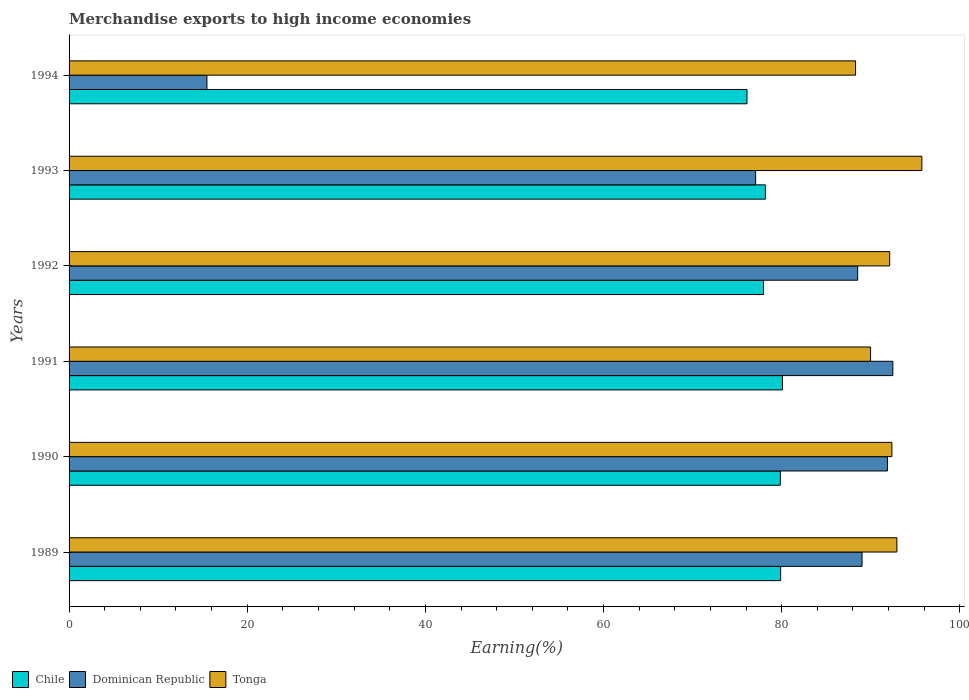How many groups of bars are there?
Give a very brief answer. 6. Are the number of bars on each tick of the Y-axis equal?
Ensure brevity in your answer.  Yes. How many bars are there on the 4th tick from the top?
Ensure brevity in your answer.  3. How many bars are there on the 2nd tick from the bottom?
Offer a very short reply. 3. What is the percentage of amount earned from merchandise exports in Tonga in 1991?
Your answer should be very brief. 89.98. Across all years, what is the maximum percentage of amount earned from merchandise exports in Tonga?
Ensure brevity in your answer.  95.74. Across all years, what is the minimum percentage of amount earned from merchandise exports in Dominican Republic?
Ensure brevity in your answer.  15.48. In which year was the percentage of amount earned from merchandise exports in Dominican Republic maximum?
Offer a terse response. 1991. In which year was the percentage of amount earned from merchandise exports in Chile minimum?
Make the answer very short. 1994. What is the total percentage of amount earned from merchandise exports in Chile in the graph?
Offer a terse response. 472.06. What is the difference between the percentage of amount earned from merchandise exports in Tonga in 1992 and that in 1994?
Offer a terse response. 3.83. What is the difference between the percentage of amount earned from merchandise exports in Chile in 1990 and the percentage of amount earned from merchandise exports in Tonga in 1991?
Your answer should be very brief. -10.13. What is the average percentage of amount earned from merchandise exports in Tonga per year?
Provide a succinct answer. 91.91. In the year 1993, what is the difference between the percentage of amount earned from merchandise exports in Chile and percentage of amount earned from merchandise exports in Dominican Republic?
Your response must be concise. 1.1. In how many years, is the percentage of amount earned from merchandise exports in Dominican Republic greater than 84 %?
Provide a succinct answer. 4. What is the ratio of the percentage of amount earned from merchandise exports in Chile in 1989 to that in 1992?
Your response must be concise. 1.02. Is the percentage of amount earned from merchandise exports in Chile in 1989 less than that in 1992?
Your answer should be compact. No. What is the difference between the highest and the second highest percentage of amount earned from merchandise exports in Tonga?
Provide a succinct answer. 2.8. What is the difference between the highest and the lowest percentage of amount earned from merchandise exports in Dominican Republic?
Offer a terse response. 77. What does the 1st bar from the top in 1991 represents?
Your answer should be compact. Tonga. What does the 2nd bar from the bottom in 1994 represents?
Ensure brevity in your answer.  Dominican Republic. Are all the bars in the graph horizontal?
Make the answer very short. Yes. How many years are there in the graph?
Your answer should be very brief. 6. Are the values on the major ticks of X-axis written in scientific E-notation?
Give a very brief answer. No. Does the graph contain any zero values?
Your answer should be compact. No. Does the graph contain grids?
Offer a terse response. No. How are the legend labels stacked?
Offer a terse response. Horizontal. What is the title of the graph?
Provide a succinct answer. Merchandise exports to high income economies. Does "Kyrgyz Republic" appear as one of the legend labels in the graph?
Keep it short and to the point. No. What is the label or title of the X-axis?
Provide a short and direct response. Earning(%). What is the Earning(%) of Chile in 1989?
Offer a very short reply. 79.88. What is the Earning(%) of Dominican Republic in 1989?
Your answer should be compact. 89.02. What is the Earning(%) in Tonga in 1989?
Offer a very short reply. 92.94. What is the Earning(%) of Chile in 1990?
Keep it short and to the point. 79.85. What is the Earning(%) of Dominican Republic in 1990?
Your answer should be compact. 91.88. What is the Earning(%) of Tonga in 1990?
Provide a succinct answer. 92.37. What is the Earning(%) in Chile in 1991?
Your response must be concise. 80.09. What is the Earning(%) of Dominican Republic in 1991?
Provide a succinct answer. 92.48. What is the Earning(%) of Tonga in 1991?
Keep it short and to the point. 89.98. What is the Earning(%) of Chile in 1992?
Offer a very short reply. 77.96. What is the Earning(%) of Dominican Republic in 1992?
Give a very brief answer. 88.53. What is the Earning(%) of Tonga in 1992?
Offer a terse response. 92.13. What is the Earning(%) in Chile in 1993?
Your answer should be compact. 78.17. What is the Earning(%) of Dominican Republic in 1993?
Ensure brevity in your answer.  77.08. What is the Earning(%) in Tonga in 1993?
Make the answer very short. 95.74. What is the Earning(%) in Chile in 1994?
Ensure brevity in your answer.  76.11. What is the Earning(%) in Dominican Republic in 1994?
Your answer should be compact. 15.48. What is the Earning(%) in Tonga in 1994?
Your answer should be very brief. 88.29. Across all years, what is the maximum Earning(%) of Chile?
Provide a short and direct response. 80.09. Across all years, what is the maximum Earning(%) in Dominican Republic?
Keep it short and to the point. 92.48. Across all years, what is the maximum Earning(%) in Tonga?
Ensure brevity in your answer.  95.74. Across all years, what is the minimum Earning(%) in Chile?
Your answer should be compact. 76.11. Across all years, what is the minimum Earning(%) of Dominican Republic?
Your answer should be compact. 15.48. Across all years, what is the minimum Earning(%) of Tonga?
Keep it short and to the point. 88.29. What is the total Earning(%) of Chile in the graph?
Give a very brief answer. 472.06. What is the total Earning(%) in Dominican Republic in the graph?
Offer a terse response. 454.46. What is the total Earning(%) in Tonga in the graph?
Your answer should be very brief. 551.45. What is the difference between the Earning(%) of Chile in 1989 and that in 1990?
Provide a short and direct response. 0.03. What is the difference between the Earning(%) in Dominican Republic in 1989 and that in 1990?
Make the answer very short. -2.85. What is the difference between the Earning(%) of Tonga in 1989 and that in 1990?
Your answer should be compact. 0.56. What is the difference between the Earning(%) of Chile in 1989 and that in 1991?
Ensure brevity in your answer.  -0.2. What is the difference between the Earning(%) of Dominican Republic in 1989 and that in 1991?
Ensure brevity in your answer.  -3.46. What is the difference between the Earning(%) in Tonga in 1989 and that in 1991?
Ensure brevity in your answer.  2.96. What is the difference between the Earning(%) of Chile in 1989 and that in 1992?
Ensure brevity in your answer.  1.92. What is the difference between the Earning(%) of Dominican Republic in 1989 and that in 1992?
Give a very brief answer. 0.49. What is the difference between the Earning(%) of Tonga in 1989 and that in 1992?
Keep it short and to the point. 0.81. What is the difference between the Earning(%) of Chile in 1989 and that in 1993?
Offer a very short reply. 1.71. What is the difference between the Earning(%) in Dominican Republic in 1989 and that in 1993?
Your answer should be compact. 11.95. What is the difference between the Earning(%) of Tonga in 1989 and that in 1993?
Give a very brief answer. -2.8. What is the difference between the Earning(%) of Chile in 1989 and that in 1994?
Your response must be concise. 3.78. What is the difference between the Earning(%) in Dominican Republic in 1989 and that in 1994?
Provide a short and direct response. 73.55. What is the difference between the Earning(%) of Tonga in 1989 and that in 1994?
Provide a short and direct response. 4.64. What is the difference between the Earning(%) of Chile in 1990 and that in 1991?
Offer a very short reply. -0.23. What is the difference between the Earning(%) of Dominican Republic in 1990 and that in 1991?
Provide a succinct answer. -0.6. What is the difference between the Earning(%) of Tonga in 1990 and that in 1991?
Offer a very short reply. 2.4. What is the difference between the Earning(%) of Chile in 1990 and that in 1992?
Keep it short and to the point. 1.89. What is the difference between the Earning(%) of Dominican Republic in 1990 and that in 1992?
Your answer should be compact. 3.34. What is the difference between the Earning(%) of Tonga in 1990 and that in 1992?
Your response must be concise. 0.25. What is the difference between the Earning(%) in Chile in 1990 and that in 1993?
Your response must be concise. 1.68. What is the difference between the Earning(%) of Dominican Republic in 1990 and that in 1993?
Make the answer very short. 14.8. What is the difference between the Earning(%) in Tonga in 1990 and that in 1993?
Keep it short and to the point. -3.36. What is the difference between the Earning(%) in Chile in 1990 and that in 1994?
Offer a very short reply. 3.75. What is the difference between the Earning(%) in Dominican Republic in 1990 and that in 1994?
Your response must be concise. 76.4. What is the difference between the Earning(%) in Tonga in 1990 and that in 1994?
Ensure brevity in your answer.  4.08. What is the difference between the Earning(%) in Chile in 1991 and that in 1992?
Your answer should be compact. 2.12. What is the difference between the Earning(%) of Dominican Republic in 1991 and that in 1992?
Provide a short and direct response. 3.95. What is the difference between the Earning(%) of Tonga in 1991 and that in 1992?
Provide a short and direct response. -2.15. What is the difference between the Earning(%) of Chile in 1991 and that in 1993?
Provide a succinct answer. 1.91. What is the difference between the Earning(%) of Dominican Republic in 1991 and that in 1993?
Your response must be concise. 15.4. What is the difference between the Earning(%) of Tonga in 1991 and that in 1993?
Your response must be concise. -5.76. What is the difference between the Earning(%) of Chile in 1991 and that in 1994?
Your answer should be very brief. 3.98. What is the difference between the Earning(%) in Dominican Republic in 1991 and that in 1994?
Your answer should be very brief. 77. What is the difference between the Earning(%) in Tonga in 1991 and that in 1994?
Provide a short and direct response. 1.68. What is the difference between the Earning(%) of Chile in 1992 and that in 1993?
Offer a very short reply. -0.21. What is the difference between the Earning(%) in Dominican Republic in 1992 and that in 1993?
Give a very brief answer. 11.46. What is the difference between the Earning(%) of Tonga in 1992 and that in 1993?
Your response must be concise. -3.61. What is the difference between the Earning(%) of Chile in 1992 and that in 1994?
Your answer should be very brief. 1.85. What is the difference between the Earning(%) in Dominican Republic in 1992 and that in 1994?
Your answer should be very brief. 73.06. What is the difference between the Earning(%) of Tonga in 1992 and that in 1994?
Your answer should be compact. 3.83. What is the difference between the Earning(%) of Chile in 1993 and that in 1994?
Provide a short and direct response. 2.06. What is the difference between the Earning(%) in Dominican Republic in 1993 and that in 1994?
Offer a very short reply. 61.6. What is the difference between the Earning(%) of Tonga in 1993 and that in 1994?
Offer a very short reply. 7.44. What is the difference between the Earning(%) of Chile in 1989 and the Earning(%) of Dominican Republic in 1990?
Make the answer very short. -11.99. What is the difference between the Earning(%) of Chile in 1989 and the Earning(%) of Tonga in 1990?
Offer a terse response. -12.49. What is the difference between the Earning(%) of Dominican Republic in 1989 and the Earning(%) of Tonga in 1990?
Make the answer very short. -3.35. What is the difference between the Earning(%) in Chile in 1989 and the Earning(%) in Dominican Republic in 1991?
Ensure brevity in your answer.  -12.59. What is the difference between the Earning(%) in Chile in 1989 and the Earning(%) in Tonga in 1991?
Your response must be concise. -10.09. What is the difference between the Earning(%) in Dominican Republic in 1989 and the Earning(%) in Tonga in 1991?
Your response must be concise. -0.96. What is the difference between the Earning(%) of Chile in 1989 and the Earning(%) of Dominican Republic in 1992?
Your answer should be compact. -8.65. What is the difference between the Earning(%) in Chile in 1989 and the Earning(%) in Tonga in 1992?
Provide a short and direct response. -12.24. What is the difference between the Earning(%) of Dominican Republic in 1989 and the Earning(%) of Tonga in 1992?
Your answer should be very brief. -3.1. What is the difference between the Earning(%) of Chile in 1989 and the Earning(%) of Dominican Republic in 1993?
Keep it short and to the point. 2.81. What is the difference between the Earning(%) in Chile in 1989 and the Earning(%) in Tonga in 1993?
Make the answer very short. -15.85. What is the difference between the Earning(%) in Dominican Republic in 1989 and the Earning(%) in Tonga in 1993?
Give a very brief answer. -6.71. What is the difference between the Earning(%) in Chile in 1989 and the Earning(%) in Dominican Republic in 1994?
Your answer should be compact. 64.41. What is the difference between the Earning(%) of Chile in 1989 and the Earning(%) of Tonga in 1994?
Provide a succinct answer. -8.41. What is the difference between the Earning(%) of Dominican Republic in 1989 and the Earning(%) of Tonga in 1994?
Give a very brief answer. 0.73. What is the difference between the Earning(%) in Chile in 1990 and the Earning(%) in Dominican Republic in 1991?
Keep it short and to the point. -12.63. What is the difference between the Earning(%) in Chile in 1990 and the Earning(%) in Tonga in 1991?
Make the answer very short. -10.13. What is the difference between the Earning(%) in Dominican Republic in 1990 and the Earning(%) in Tonga in 1991?
Offer a terse response. 1.9. What is the difference between the Earning(%) of Chile in 1990 and the Earning(%) of Dominican Republic in 1992?
Your answer should be compact. -8.68. What is the difference between the Earning(%) of Chile in 1990 and the Earning(%) of Tonga in 1992?
Ensure brevity in your answer.  -12.27. What is the difference between the Earning(%) in Dominican Republic in 1990 and the Earning(%) in Tonga in 1992?
Your answer should be very brief. -0.25. What is the difference between the Earning(%) of Chile in 1990 and the Earning(%) of Dominican Republic in 1993?
Make the answer very short. 2.78. What is the difference between the Earning(%) in Chile in 1990 and the Earning(%) in Tonga in 1993?
Your answer should be very brief. -15.88. What is the difference between the Earning(%) in Dominican Republic in 1990 and the Earning(%) in Tonga in 1993?
Provide a succinct answer. -3.86. What is the difference between the Earning(%) of Chile in 1990 and the Earning(%) of Dominican Republic in 1994?
Provide a succinct answer. 64.38. What is the difference between the Earning(%) in Chile in 1990 and the Earning(%) in Tonga in 1994?
Your response must be concise. -8.44. What is the difference between the Earning(%) of Dominican Republic in 1990 and the Earning(%) of Tonga in 1994?
Offer a terse response. 3.58. What is the difference between the Earning(%) of Chile in 1991 and the Earning(%) of Dominican Republic in 1992?
Provide a short and direct response. -8.45. What is the difference between the Earning(%) in Chile in 1991 and the Earning(%) in Tonga in 1992?
Your answer should be compact. -12.04. What is the difference between the Earning(%) of Dominican Republic in 1991 and the Earning(%) of Tonga in 1992?
Ensure brevity in your answer.  0.35. What is the difference between the Earning(%) in Chile in 1991 and the Earning(%) in Dominican Republic in 1993?
Offer a very short reply. 3.01. What is the difference between the Earning(%) in Chile in 1991 and the Earning(%) in Tonga in 1993?
Offer a very short reply. -15.65. What is the difference between the Earning(%) in Dominican Republic in 1991 and the Earning(%) in Tonga in 1993?
Your answer should be compact. -3.26. What is the difference between the Earning(%) in Chile in 1991 and the Earning(%) in Dominican Republic in 1994?
Your response must be concise. 64.61. What is the difference between the Earning(%) of Chile in 1991 and the Earning(%) of Tonga in 1994?
Your response must be concise. -8.21. What is the difference between the Earning(%) in Dominican Republic in 1991 and the Earning(%) in Tonga in 1994?
Make the answer very short. 4.18. What is the difference between the Earning(%) of Chile in 1992 and the Earning(%) of Dominican Republic in 1993?
Your answer should be compact. 0.89. What is the difference between the Earning(%) of Chile in 1992 and the Earning(%) of Tonga in 1993?
Offer a terse response. -17.77. What is the difference between the Earning(%) of Dominican Republic in 1992 and the Earning(%) of Tonga in 1993?
Your response must be concise. -7.21. What is the difference between the Earning(%) in Chile in 1992 and the Earning(%) in Dominican Republic in 1994?
Your answer should be compact. 62.49. What is the difference between the Earning(%) in Chile in 1992 and the Earning(%) in Tonga in 1994?
Offer a very short reply. -10.33. What is the difference between the Earning(%) in Dominican Republic in 1992 and the Earning(%) in Tonga in 1994?
Keep it short and to the point. 0.24. What is the difference between the Earning(%) of Chile in 1993 and the Earning(%) of Dominican Republic in 1994?
Your response must be concise. 62.7. What is the difference between the Earning(%) in Chile in 1993 and the Earning(%) in Tonga in 1994?
Give a very brief answer. -10.12. What is the difference between the Earning(%) of Dominican Republic in 1993 and the Earning(%) of Tonga in 1994?
Your answer should be very brief. -11.22. What is the average Earning(%) in Chile per year?
Keep it short and to the point. 78.68. What is the average Earning(%) in Dominican Republic per year?
Offer a very short reply. 75.74. What is the average Earning(%) of Tonga per year?
Your answer should be compact. 91.91. In the year 1989, what is the difference between the Earning(%) of Chile and Earning(%) of Dominican Republic?
Provide a succinct answer. -9.14. In the year 1989, what is the difference between the Earning(%) in Chile and Earning(%) in Tonga?
Ensure brevity in your answer.  -13.05. In the year 1989, what is the difference between the Earning(%) in Dominican Republic and Earning(%) in Tonga?
Your response must be concise. -3.91. In the year 1990, what is the difference between the Earning(%) in Chile and Earning(%) in Dominican Republic?
Provide a succinct answer. -12.02. In the year 1990, what is the difference between the Earning(%) in Chile and Earning(%) in Tonga?
Give a very brief answer. -12.52. In the year 1990, what is the difference between the Earning(%) in Dominican Republic and Earning(%) in Tonga?
Your answer should be compact. -0.5. In the year 1991, what is the difference between the Earning(%) in Chile and Earning(%) in Dominican Republic?
Keep it short and to the point. -12.39. In the year 1991, what is the difference between the Earning(%) in Chile and Earning(%) in Tonga?
Ensure brevity in your answer.  -9.89. In the year 1991, what is the difference between the Earning(%) of Dominican Republic and Earning(%) of Tonga?
Your answer should be very brief. 2.5. In the year 1992, what is the difference between the Earning(%) of Chile and Earning(%) of Dominican Republic?
Offer a very short reply. -10.57. In the year 1992, what is the difference between the Earning(%) of Chile and Earning(%) of Tonga?
Your answer should be very brief. -14.16. In the year 1992, what is the difference between the Earning(%) in Dominican Republic and Earning(%) in Tonga?
Make the answer very short. -3.59. In the year 1993, what is the difference between the Earning(%) of Chile and Earning(%) of Dominican Republic?
Your answer should be very brief. 1.1. In the year 1993, what is the difference between the Earning(%) in Chile and Earning(%) in Tonga?
Offer a terse response. -17.57. In the year 1993, what is the difference between the Earning(%) of Dominican Republic and Earning(%) of Tonga?
Provide a short and direct response. -18.66. In the year 1994, what is the difference between the Earning(%) of Chile and Earning(%) of Dominican Republic?
Your answer should be compact. 60.63. In the year 1994, what is the difference between the Earning(%) of Chile and Earning(%) of Tonga?
Provide a succinct answer. -12.19. In the year 1994, what is the difference between the Earning(%) in Dominican Republic and Earning(%) in Tonga?
Provide a short and direct response. -72.82. What is the ratio of the Earning(%) of Chile in 1989 to that in 1990?
Your response must be concise. 1. What is the ratio of the Earning(%) in Dominican Republic in 1989 to that in 1990?
Provide a short and direct response. 0.97. What is the ratio of the Earning(%) of Chile in 1989 to that in 1991?
Offer a terse response. 1. What is the ratio of the Earning(%) in Dominican Republic in 1989 to that in 1991?
Your answer should be compact. 0.96. What is the ratio of the Earning(%) in Tonga in 1989 to that in 1991?
Your answer should be compact. 1.03. What is the ratio of the Earning(%) of Chile in 1989 to that in 1992?
Your answer should be compact. 1.02. What is the ratio of the Earning(%) of Dominican Republic in 1989 to that in 1992?
Offer a very short reply. 1.01. What is the ratio of the Earning(%) in Tonga in 1989 to that in 1992?
Ensure brevity in your answer.  1.01. What is the ratio of the Earning(%) of Chile in 1989 to that in 1993?
Offer a terse response. 1.02. What is the ratio of the Earning(%) in Dominican Republic in 1989 to that in 1993?
Make the answer very short. 1.16. What is the ratio of the Earning(%) of Tonga in 1989 to that in 1993?
Keep it short and to the point. 0.97. What is the ratio of the Earning(%) in Chile in 1989 to that in 1994?
Offer a very short reply. 1.05. What is the ratio of the Earning(%) in Dominican Republic in 1989 to that in 1994?
Make the answer very short. 5.75. What is the ratio of the Earning(%) of Tonga in 1989 to that in 1994?
Your answer should be compact. 1.05. What is the ratio of the Earning(%) in Dominican Republic in 1990 to that in 1991?
Your answer should be very brief. 0.99. What is the ratio of the Earning(%) of Tonga in 1990 to that in 1991?
Make the answer very short. 1.03. What is the ratio of the Earning(%) of Chile in 1990 to that in 1992?
Your answer should be compact. 1.02. What is the ratio of the Earning(%) of Dominican Republic in 1990 to that in 1992?
Keep it short and to the point. 1.04. What is the ratio of the Earning(%) in Chile in 1990 to that in 1993?
Your answer should be compact. 1.02. What is the ratio of the Earning(%) of Dominican Republic in 1990 to that in 1993?
Offer a very short reply. 1.19. What is the ratio of the Earning(%) of Tonga in 1990 to that in 1993?
Keep it short and to the point. 0.96. What is the ratio of the Earning(%) in Chile in 1990 to that in 1994?
Provide a succinct answer. 1.05. What is the ratio of the Earning(%) in Dominican Republic in 1990 to that in 1994?
Your response must be concise. 5.94. What is the ratio of the Earning(%) of Tonga in 1990 to that in 1994?
Offer a terse response. 1.05. What is the ratio of the Earning(%) in Chile in 1991 to that in 1992?
Your answer should be very brief. 1.03. What is the ratio of the Earning(%) in Dominican Republic in 1991 to that in 1992?
Offer a very short reply. 1.04. What is the ratio of the Earning(%) in Tonga in 1991 to that in 1992?
Ensure brevity in your answer.  0.98. What is the ratio of the Earning(%) in Chile in 1991 to that in 1993?
Make the answer very short. 1.02. What is the ratio of the Earning(%) of Dominican Republic in 1991 to that in 1993?
Provide a succinct answer. 1.2. What is the ratio of the Earning(%) of Tonga in 1991 to that in 1993?
Your answer should be very brief. 0.94. What is the ratio of the Earning(%) in Chile in 1991 to that in 1994?
Provide a short and direct response. 1.05. What is the ratio of the Earning(%) of Dominican Republic in 1991 to that in 1994?
Provide a succinct answer. 5.98. What is the ratio of the Earning(%) in Tonga in 1991 to that in 1994?
Offer a terse response. 1.02. What is the ratio of the Earning(%) in Dominican Republic in 1992 to that in 1993?
Keep it short and to the point. 1.15. What is the ratio of the Earning(%) of Tonga in 1992 to that in 1993?
Your response must be concise. 0.96. What is the ratio of the Earning(%) in Chile in 1992 to that in 1994?
Ensure brevity in your answer.  1.02. What is the ratio of the Earning(%) in Dominican Republic in 1992 to that in 1994?
Your answer should be very brief. 5.72. What is the ratio of the Earning(%) in Tonga in 1992 to that in 1994?
Your answer should be compact. 1.04. What is the ratio of the Earning(%) in Chile in 1993 to that in 1994?
Ensure brevity in your answer.  1.03. What is the ratio of the Earning(%) of Dominican Republic in 1993 to that in 1994?
Keep it short and to the point. 4.98. What is the ratio of the Earning(%) in Tonga in 1993 to that in 1994?
Your response must be concise. 1.08. What is the difference between the highest and the second highest Earning(%) in Chile?
Your response must be concise. 0.2. What is the difference between the highest and the second highest Earning(%) in Dominican Republic?
Keep it short and to the point. 0.6. What is the difference between the highest and the second highest Earning(%) in Tonga?
Your answer should be compact. 2.8. What is the difference between the highest and the lowest Earning(%) of Chile?
Your response must be concise. 3.98. What is the difference between the highest and the lowest Earning(%) in Dominican Republic?
Ensure brevity in your answer.  77. What is the difference between the highest and the lowest Earning(%) of Tonga?
Your answer should be compact. 7.44. 